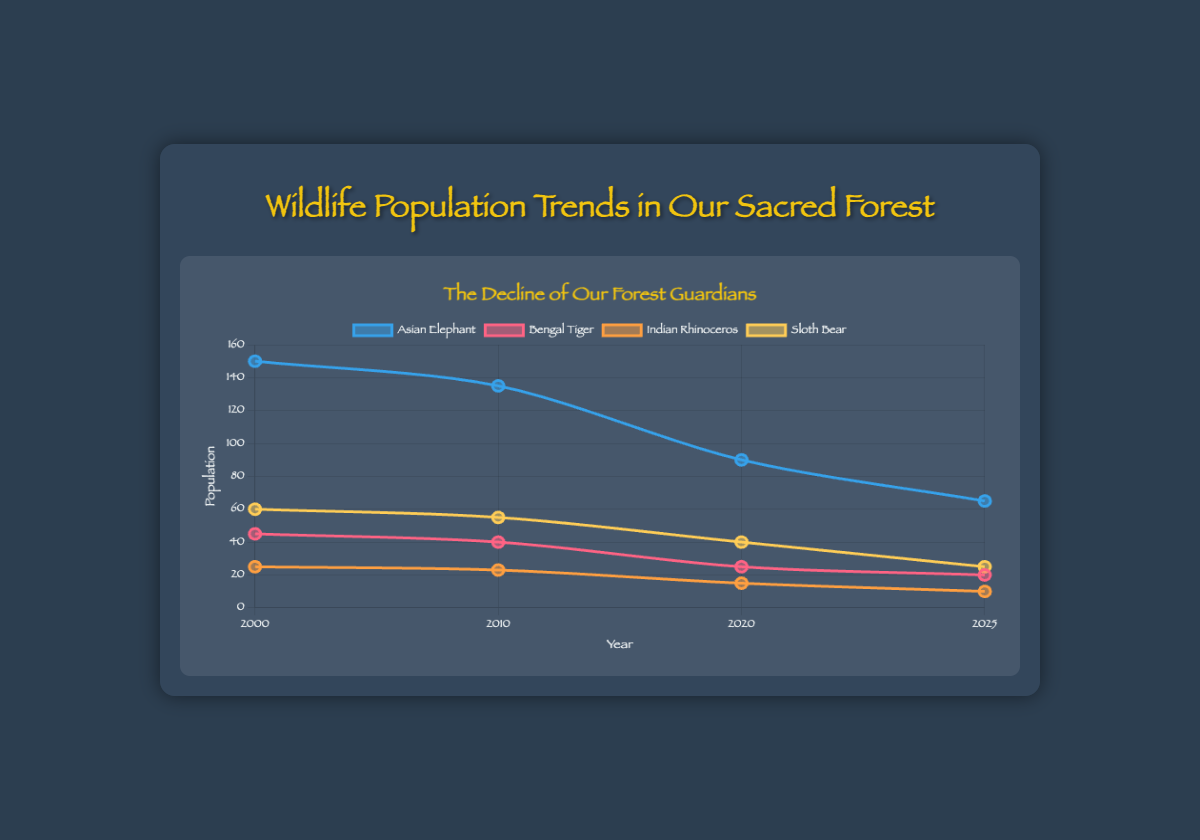What is the population trend of the Asian Elephant from 2000 to 2025? From the figure, we can see the population of Asian Elephants in 2000 is 150. It decreases to 135 in 2010, drops further to 90 in 2020, and reaches 65 in 2025. This indicates a consistent decline in the population over the years.
Answer: Consistently decreasing Which species had the highest population in the year 2000? Referring to the visual information for the year 2000, the populations are compared across species. The Asian Elephant has the highest population at 150.
Answer: Asian Elephant Compare the population changes of the Bengal Tiger and Indian Rhinoceros between 2000 and 2010. In the year 2000, the Bengal Tiger's population is 45 and drops to 40 by 2010, a decrease of 5. The Indian Rhinoceros' population is 25 in 2000 and decreases to 23 by 2010, a decrease of 2.
Answer: Bengal Tiger: -5, Indian Rhinoceros: -2 Which species experienced the largest population decline by 2025? By analyzing the population values from 2000 to 2025 for each species, the Asian Elephant shows the largest decline from 150 in 2000 to 65 in 2025, a decline of 85.
Answer: Asian Elephant In which year did the population of the Sloth Bear first fall below 50? Checking the visual trends for the Sloth Bear, its population is 60 in 2000, 55 in 2010, 40 in 2020. The year it first falls below 50 is 2020.
Answer: 2020 What is the average population of the Bengal Tiger over the observed years? The Bengal Tiger population over the years is: 2000: 45, 2010: 40, 2020: 25, 2025: 20. Sum these values: (45 + 40 + 25 + 20) = 130, and divide by the number of years (4). The average is 130/4 = 32.5
Answer: 32.5 Compare the populations of the Asian Elephant and Sloth Bear in 2020. Which one is higher? Referring to the year 2020 in the figure, the Asian Elephant population is 90 and the Sloth Bear population is 40. Asian Elephant's population is higher.
Answer: Asian Elephant What is the total population of all species combined in the year 2025? Summing up the populations of all species in 2025: Asian Elephant: 65, Bengal Tiger: 20, Indian Rhinoceros: 10, Sloth Bear: 25. Total = 65 + 20 + 10 + 25 = 120.
Answer: 120 How many species had populations greater than 20 in the year 2025? Referring to the population data for 2025: Asian Elephant (65), Bengal Tiger (20), Indian Rhinoceros (10), Sloth Bear (25). The species with populations greater than 20 are Asian Elephant and Sloth Bear.
Answer: 2 By how much did the Indian Rhinoceros population decrease from 2000 to 2025? The population of the Indian Rhinoceros in 2000 is 25 and in 2025 it is 10. The decrease is calculated as 25 - 10 = 15.
Answer: 15 